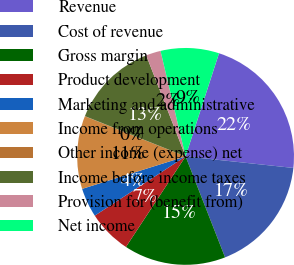<chart> <loc_0><loc_0><loc_500><loc_500><pie_chart><fcel>Revenue<fcel>Cost of revenue<fcel>Gross margin<fcel>Product development<fcel>Marketing and administrative<fcel>Income from operations<fcel>Other income (expense) net<fcel>Income before income taxes<fcel>Provision for (benefit from)<fcel>Net income<nl><fcel>21.71%<fcel>17.37%<fcel>15.2%<fcel>6.53%<fcel>4.36%<fcel>10.87%<fcel>0.03%<fcel>13.03%<fcel>2.2%<fcel>8.7%<nl></chart> 